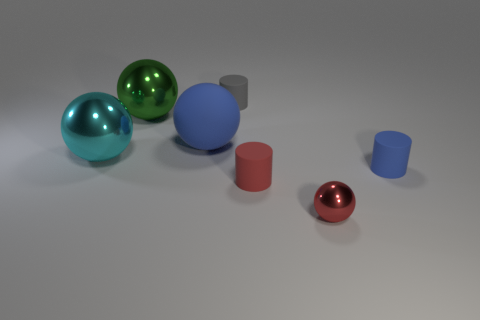Subtract all tiny metallic spheres. How many spheres are left? 3 Subtract 2 spheres. How many spheres are left? 2 Subtract all green balls. How many balls are left? 3 Subtract all gray spheres. Subtract all brown cylinders. How many spheres are left? 4 Add 3 large metallic spheres. How many objects exist? 10 Subtract all cylinders. How many objects are left? 4 Subtract all rubber objects. Subtract all blue balls. How many objects are left? 2 Add 3 tiny things. How many tiny things are left? 7 Add 4 green balls. How many green balls exist? 5 Subtract 0 yellow balls. How many objects are left? 7 